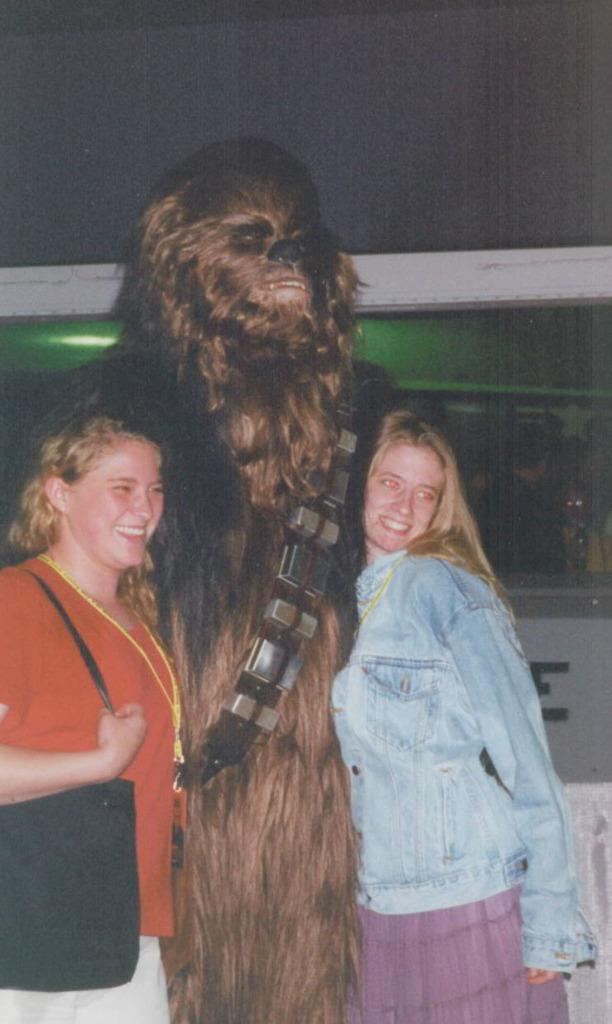How many people are in the image? There are two women in the image. What is the person wearing in the image? There is a person wearing an animal costume in the image. What is the facial expression of the women in the image? Both women are smiling in the image. What are the women doing in the image? The women are posing for a photo. What is the relation between the women and the person wearing the animal costume in the image? There is no information provided about the relationship between the women and the person wearing the animal costume in the image. How many hospital beds are visible in the image? There are no hospital beds present in the image. 